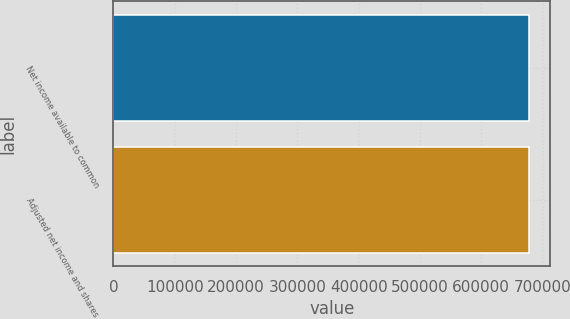<chart> <loc_0><loc_0><loc_500><loc_500><bar_chart><fcel>Net income available to common<fcel>Adjusted net income and shares<nl><fcel>678428<fcel>678428<nl></chart> 